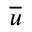Convert formula to latex. <formula><loc_0><loc_0><loc_500><loc_500>\overline { u }</formula> 